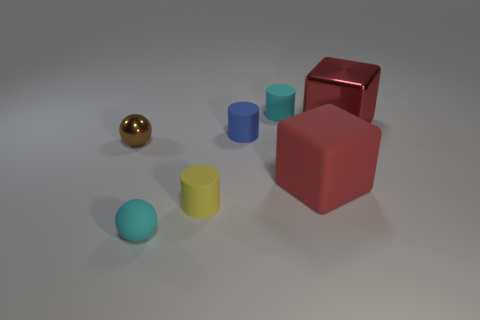There is a tiny cylinder behind the small blue matte object; what is its color?
Provide a succinct answer. Cyan. How many other objects are the same size as the blue object?
Keep it short and to the point. 4. Is there any other thing that is the same shape as the brown thing?
Your response must be concise. Yes. Are there the same number of small yellow things behind the small blue matte cylinder and tiny yellow shiny blocks?
Your response must be concise. Yes. What number of big brown balls are made of the same material as the brown thing?
Give a very brief answer. 0. There is a ball that is the same material as the small yellow thing; what color is it?
Provide a succinct answer. Cyan. Does the yellow matte thing have the same shape as the small blue thing?
Provide a short and direct response. Yes. There is a tiny ball behind the cyan rubber thing in front of the cyan rubber cylinder; are there any small cyan cylinders on the left side of it?
Provide a short and direct response. No. What number of small cylinders have the same color as the tiny shiny object?
Keep it short and to the point. 0. There is a blue matte object that is the same size as the cyan rubber cylinder; what is its shape?
Keep it short and to the point. Cylinder. 